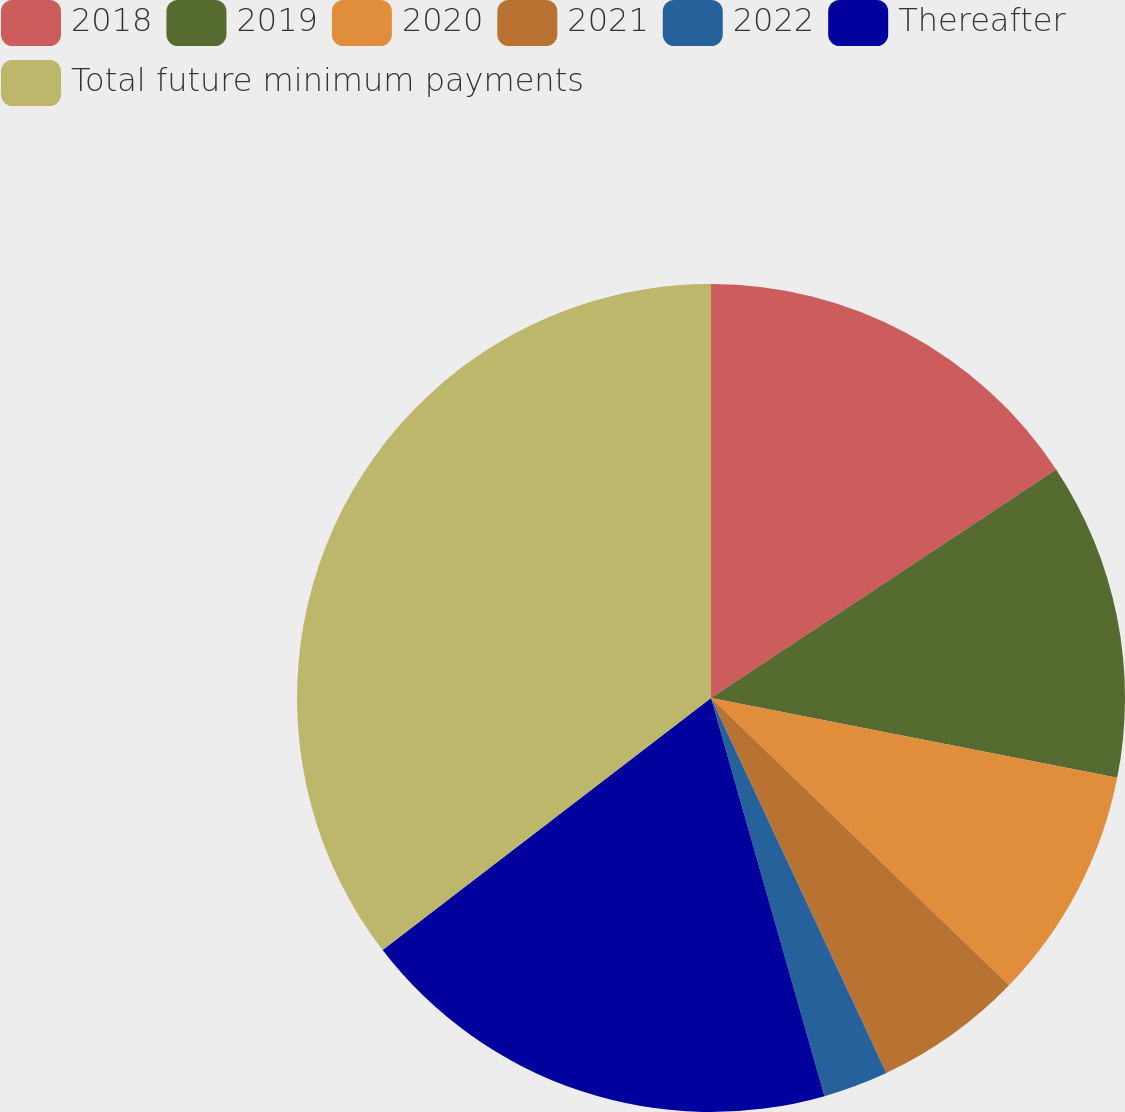Convert chart. <chart><loc_0><loc_0><loc_500><loc_500><pie_chart><fcel>2018<fcel>2019<fcel>2020<fcel>2021<fcel>2022<fcel>Thereafter<fcel>Total future minimum payments<nl><fcel>15.69%<fcel>12.4%<fcel>9.12%<fcel>5.83%<fcel>2.54%<fcel>19.0%<fcel>35.42%<nl></chart> 